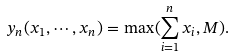Convert formula to latex. <formula><loc_0><loc_0><loc_500><loc_500>y _ { n } ( x _ { 1 } , \cdots , x _ { n } ) = \max ( \sum _ { i = 1 } ^ { n } x _ { i } , M ) .</formula> 